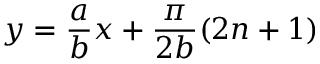<formula> <loc_0><loc_0><loc_500><loc_500>y = \frac { a } { b } x + \frac { \pi } { 2 b } ( 2 n + 1 )</formula> 